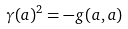<formula> <loc_0><loc_0><loc_500><loc_500>\gamma ( a ) ^ { 2 } = - g ( a , a )</formula> 